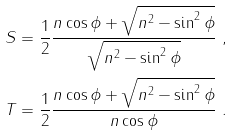<formula> <loc_0><loc_0><loc_500><loc_500>S & = \frac { 1 } { 2 } \frac { n \cos \phi + \sqrt { n ^ { 2 } - \sin ^ { 2 } \phi } } { \sqrt { n ^ { 2 } - \sin ^ { 2 } \phi } } \ , \\ T & = \frac { 1 } { 2 } \frac { n \cos \phi + \sqrt { n ^ { 2 } - \sin ^ { 2 } \phi } } { n \cos \phi } \ .</formula> 